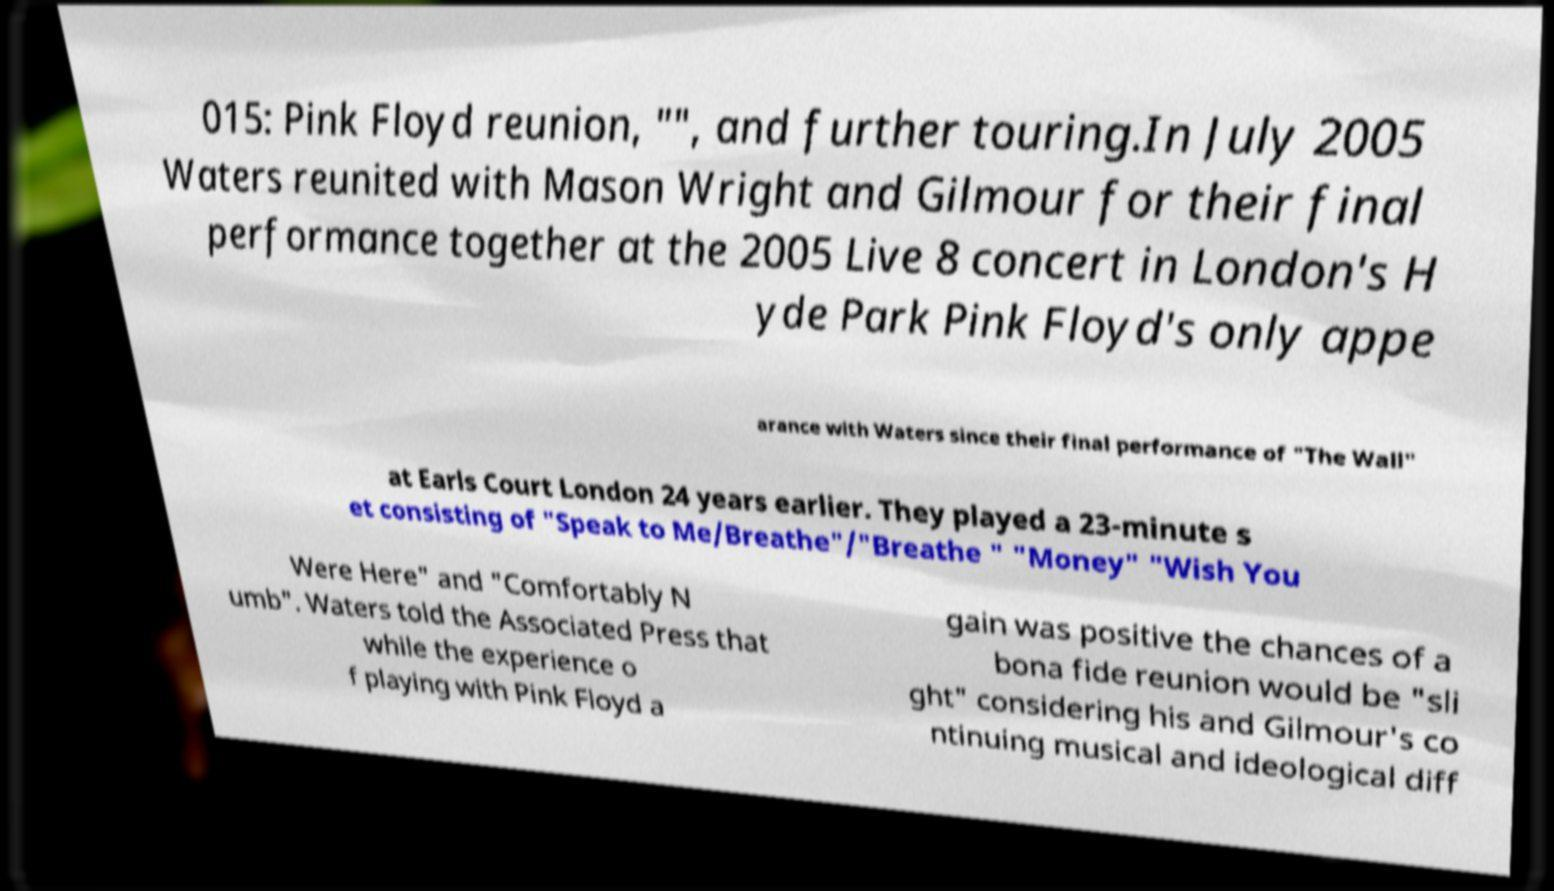Please identify and transcribe the text found in this image. 015: Pink Floyd reunion, "", and further touring.In July 2005 Waters reunited with Mason Wright and Gilmour for their final performance together at the 2005 Live 8 concert in London's H yde Park Pink Floyd's only appe arance with Waters since their final performance of "The Wall" at Earls Court London 24 years earlier. They played a 23-minute s et consisting of "Speak to Me/Breathe"/"Breathe " "Money" "Wish You Were Here" and "Comfortably N umb". Waters told the Associated Press that while the experience o f playing with Pink Floyd a gain was positive the chances of a bona fide reunion would be "sli ght" considering his and Gilmour's co ntinuing musical and ideological diff 